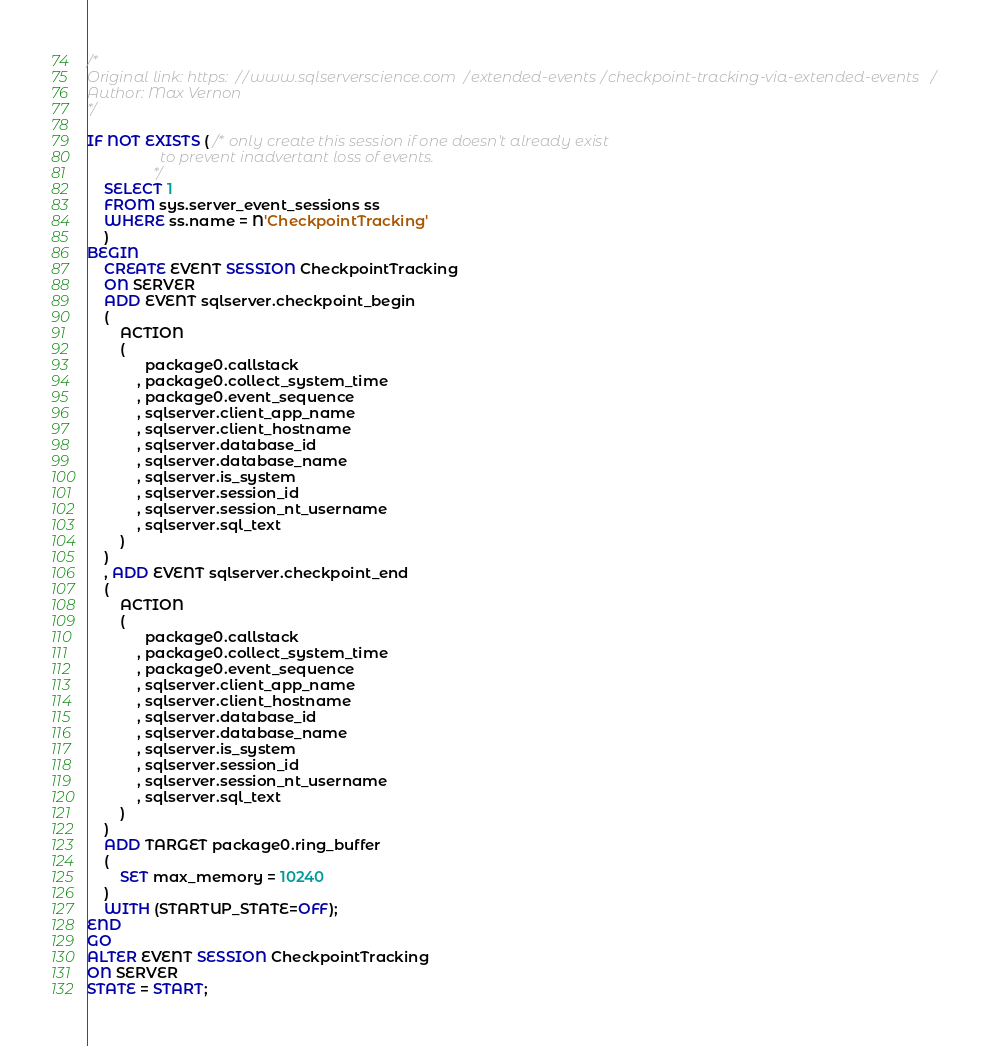Convert code to text. <code><loc_0><loc_0><loc_500><loc_500><_SQL_>/*
Original link: https://www.sqlserverscience.com/extended-events/checkpoint-tracking-via-extended-events/
Author: Max Vernon
*/

IF NOT EXISTS ( /* only create this session if one doesn't already exist
                   to prevent inadvertant loss of events.
                */
    SELECT 1
    FROM sys.server_event_sessions ss
    WHERE ss.name = N'CheckpointTracking'
    )
BEGIN
    CREATE EVENT SESSION CheckpointTracking 
    ON SERVER 
    ADD EVENT sqlserver.checkpoint_begin
    (
        ACTION
        (
              package0.callstack
            , package0.collect_system_time
            , package0.event_sequence
            , sqlserver.client_app_name
            , sqlserver.client_hostname
            , sqlserver.database_id
            , sqlserver.database_name
            , sqlserver.is_system
            , sqlserver.session_id
            , sqlserver.session_nt_username
            , sqlserver.sql_text
        )
    )
    , ADD EVENT sqlserver.checkpoint_end
    (
        ACTION
        (
              package0.callstack
            , package0.collect_system_time
            , package0.event_sequence
            , sqlserver.client_app_name
            , sqlserver.client_hostname
            , sqlserver.database_id
            , sqlserver.database_name
            , sqlserver.is_system
            , sqlserver.session_id
            , sqlserver.session_nt_username
            , sqlserver.sql_text
        )
    )
    ADD TARGET package0.ring_buffer
    (
        SET max_memory = 10240
    )
    WITH (STARTUP_STATE=OFF);
END
GO
ALTER EVENT SESSION CheckpointTracking 
ON SERVER 
STATE = START;
</code> 